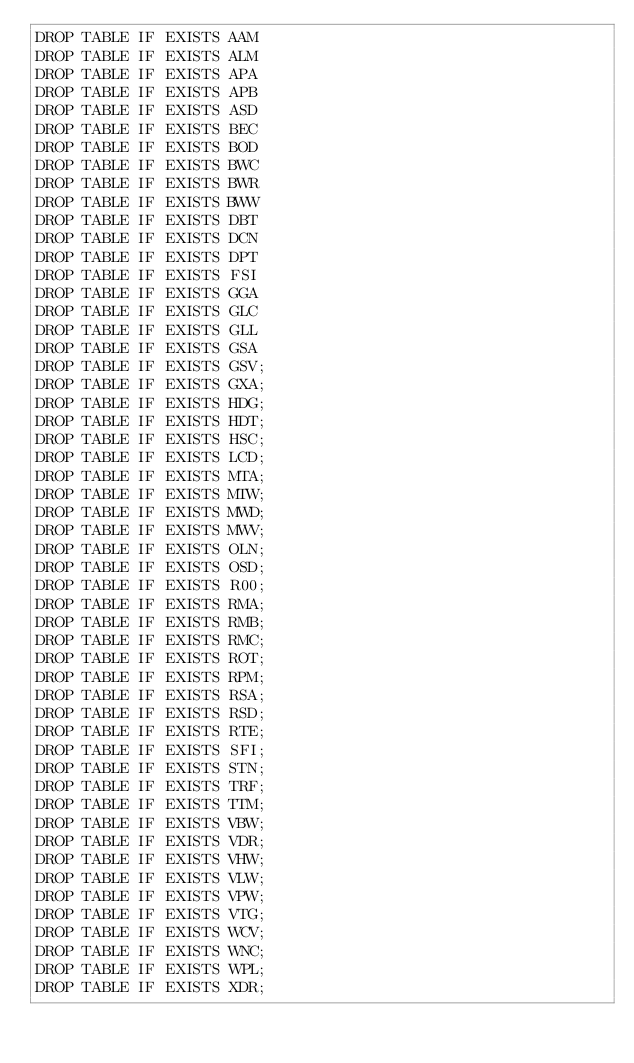Convert code to text. <code><loc_0><loc_0><loc_500><loc_500><_SQL_>DROP TABLE IF EXISTS AAM
DROP TABLE IF EXISTS ALM
DROP TABLE IF EXISTS APA
DROP TABLE IF EXISTS APB
DROP TABLE IF EXISTS ASD
DROP TABLE IF EXISTS BEC
DROP TABLE IF EXISTS BOD
DROP TABLE IF EXISTS BWC
DROP TABLE IF EXISTS BWR
DROP TABLE IF EXISTS BWW
DROP TABLE IF EXISTS DBT
DROP TABLE IF EXISTS DCN
DROP TABLE IF EXISTS DPT
DROP TABLE IF EXISTS FSI
DROP TABLE IF EXISTS GGA
DROP TABLE IF EXISTS GLC
DROP TABLE IF EXISTS GLL
DROP TABLE IF EXISTS GSA
DROP TABLE IF EXISTS GSV;
DROP TABLE IF EXISTS GXA;
DROP TABLE IF EXISTS HDG;
DROP TABLE IF EXISTS HDT;
DROP TABLE IF EXISTS HSC;
DROP TABLE IF EXISTS LCD;
DROP TABLE IF EXISTS MTA;
DROP TABLE IF EXISTS MTW;
DROP TABLE IF EXISTS MWD;
DROP TABLE IF EXISTS MWV;
DROP TABLE IF EXISTS OLN;
DROP TABLE IF EXISTS OSD;
DROP TABLE IF EXISTS R00;
DROP TABLE IF EXISTS RMA;
DROP TABLE IF EXISTS RMB;
DROP TABLE IF EXISTS RMC;
DROP TABLE IF EXISTS ROT;
DROP TABLE IF EXISTS RPM;
DROP TABLE IF EXISTS RSA;
DROP TABLE IF EXISTS RSD;
DROP TABLE IF EXISTS RTE;
DROP TABLE IF EXISTS SFI;
DROP TABLE IF EXISTS STN;
DROP TABLE IF EXISTS TRF;
DROP TABLE IF EXISTS TTM;
DROP TABLE IF EXISTS VBW;
DROP TABLE IF EXISTS VDR;
DROP TABLE IF EXISTS VHW;
DROP TABLE IF EXISTS VLW;
DROP TABLE IF EXISTS VPW;
DROP TABLE IF EXISTS VTG;
DROP TABLE IF EXISTS WCV;
DROP TABLE IF EXISTS WNC;
DROP TABLE IF EXISTS WPL;
DROP TABLE IF EXISTS XDR;</code> 